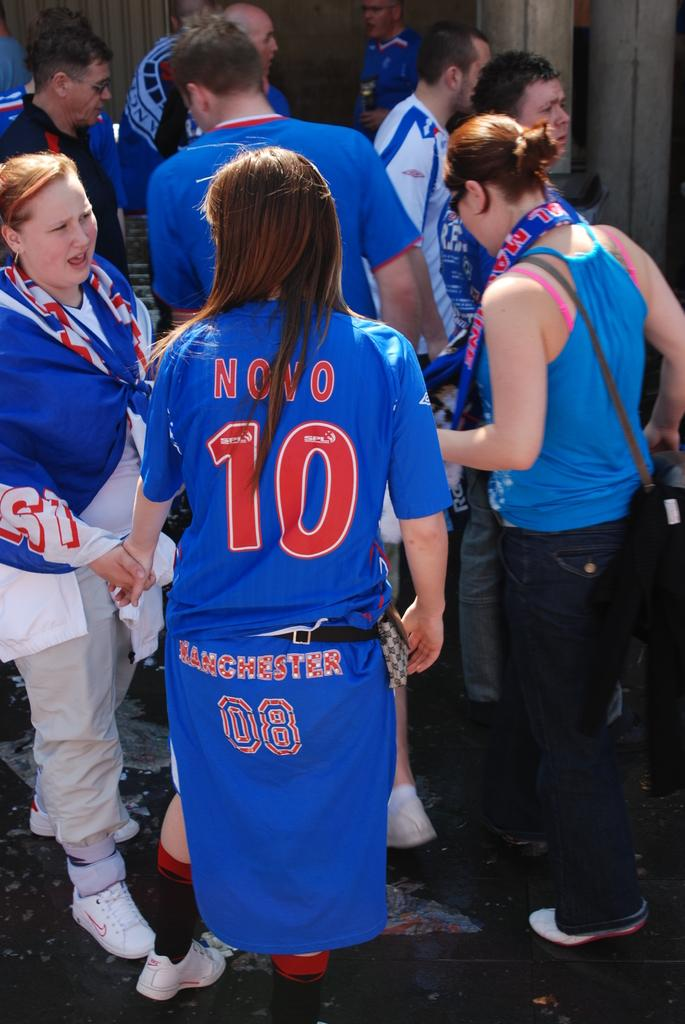<image>
Give a short and clear explanation of the subsequent image. Two women speak to each other while one of them wears a Manchester jersey around the waist. 